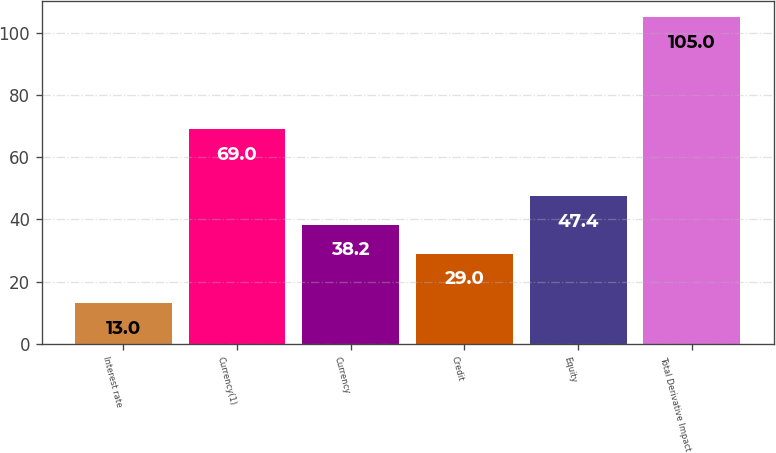<chart> <loc_0><loc_0><loc_500><loc_500><bar_chart><fcel>Interest rate<fcel>Currency(1)<fcel>Currency<fcel>Credit<fcel>Equity<fcel>Total Derivative Impact<nl><fcel>13<fcel>69<fcel>38.2<fcel>29<fcel>47.4<fcel>105<nl></chart> 